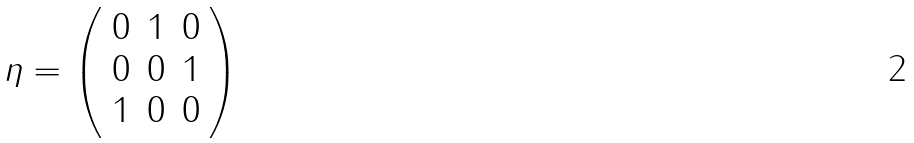Convert formula to latex. <formula><loc_0><loc_0><loc_500><loc_500>\eta = \left ( \begin{array} { c c c } 0 & 1 & 0 \\ 0 & 0 & 1 \\ 1 & 0 & 0 \end{array} \right )</formula> 